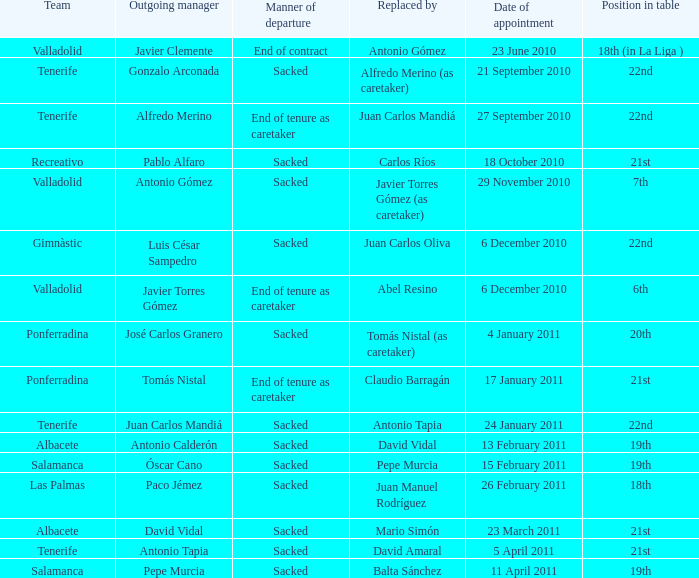What was the job title designated on 17 january 2011? 21st. 